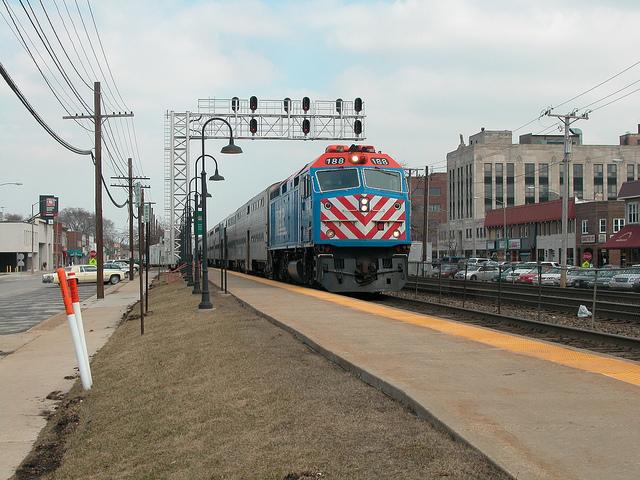How would you describe where the train is running?
Concise answer only. Tracks. What is blue color?
Keep it brief. Train. Where is the train going?
Write a very short answer. Station. What color is the train?
Short answer required. Blue. Can you spot cars?
Concise answer only. Yes. Is this a city commuter train?
Quick response, please. Yes. 